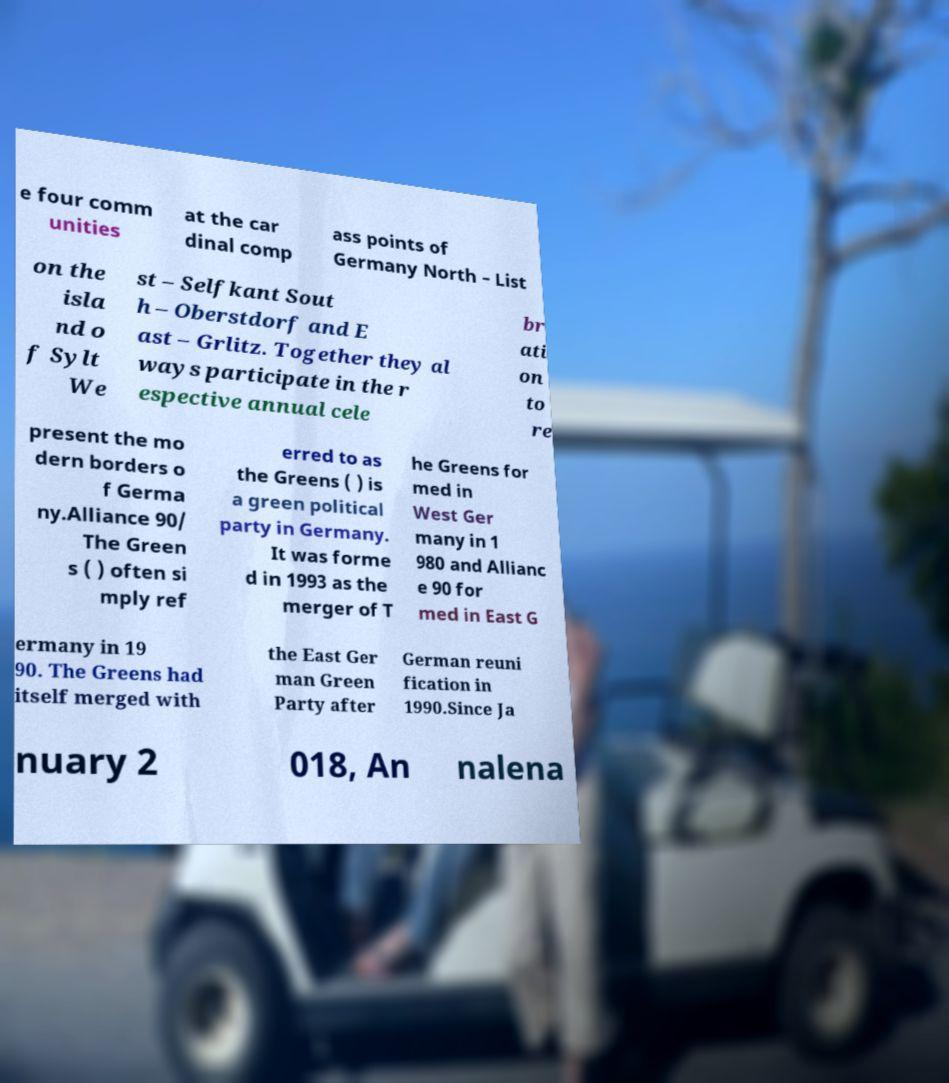Please identify and transcribe the text found in this image. e four comm unities at the car dinal comp ass points of Germany North – List on the isla nd o f Sylt We st – Selfkant Sout h – Oberstdorf and E ast – Grlitz. Together they al ways participate in the r espective annual cele br ati on to re present the mo dern borders o f Germa ny.Alliance 90/ The Green s ( ) often si mply ref erred to as the Greens ( ) is a green political party in Germany. It was forme d in 1993 as the merger of T he Greens for med in West Ger many in 1 980 and Allianc e 90 for med in East G ermany in 19 90. The Greens had itself merged with the East Ger man Green Party after German reuni fication in 1990.Since Ja nuary 2 018, An nalena 